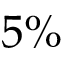Convert formula to latex. <formula><loc_0><loc_0><loc_500><loc_500>5 \%</formula> 